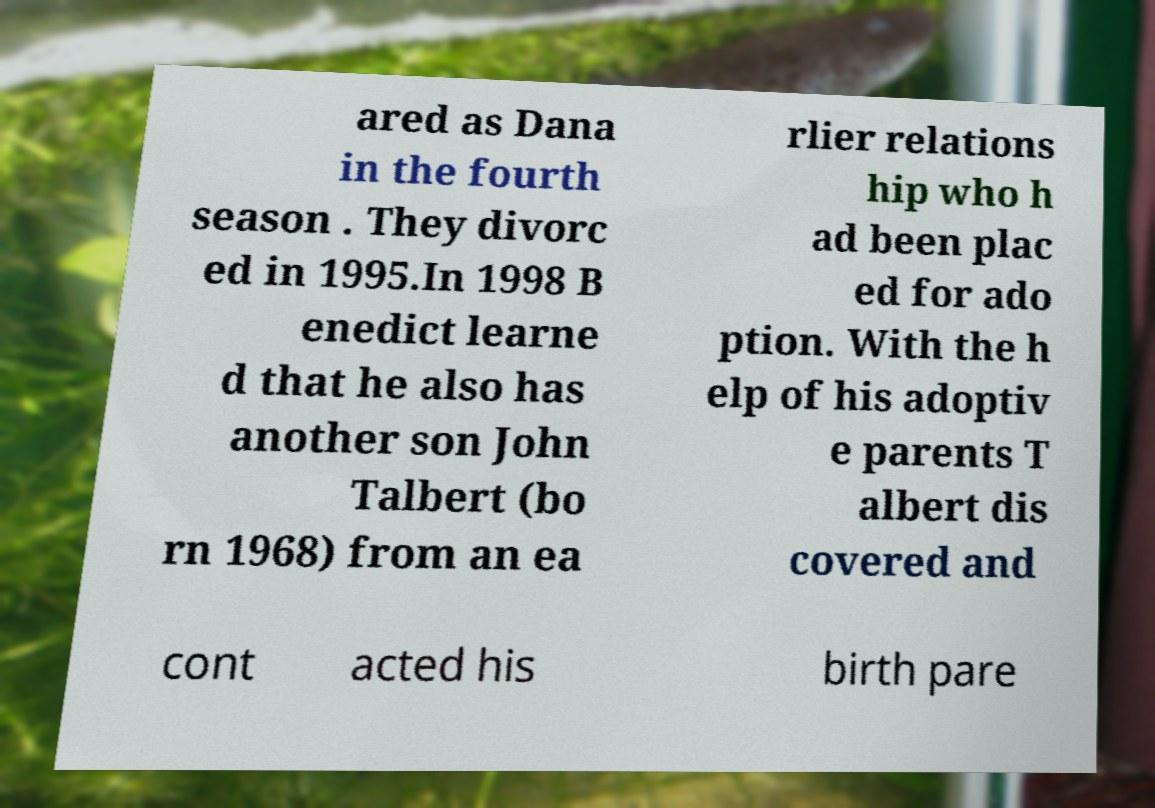Please read and relay the text visible in this image. What does it say? ared as Dana in the fourth season . They divorc ed in 1995.In 1998 B enedict learne d that he also has another son John Talbert (bo rn 1968) from an ea rlier relations hip who h ad been plac ed for ado ption. With the h elp of his adoptiv e parents T albert dis covered and cont acted his birth pare 